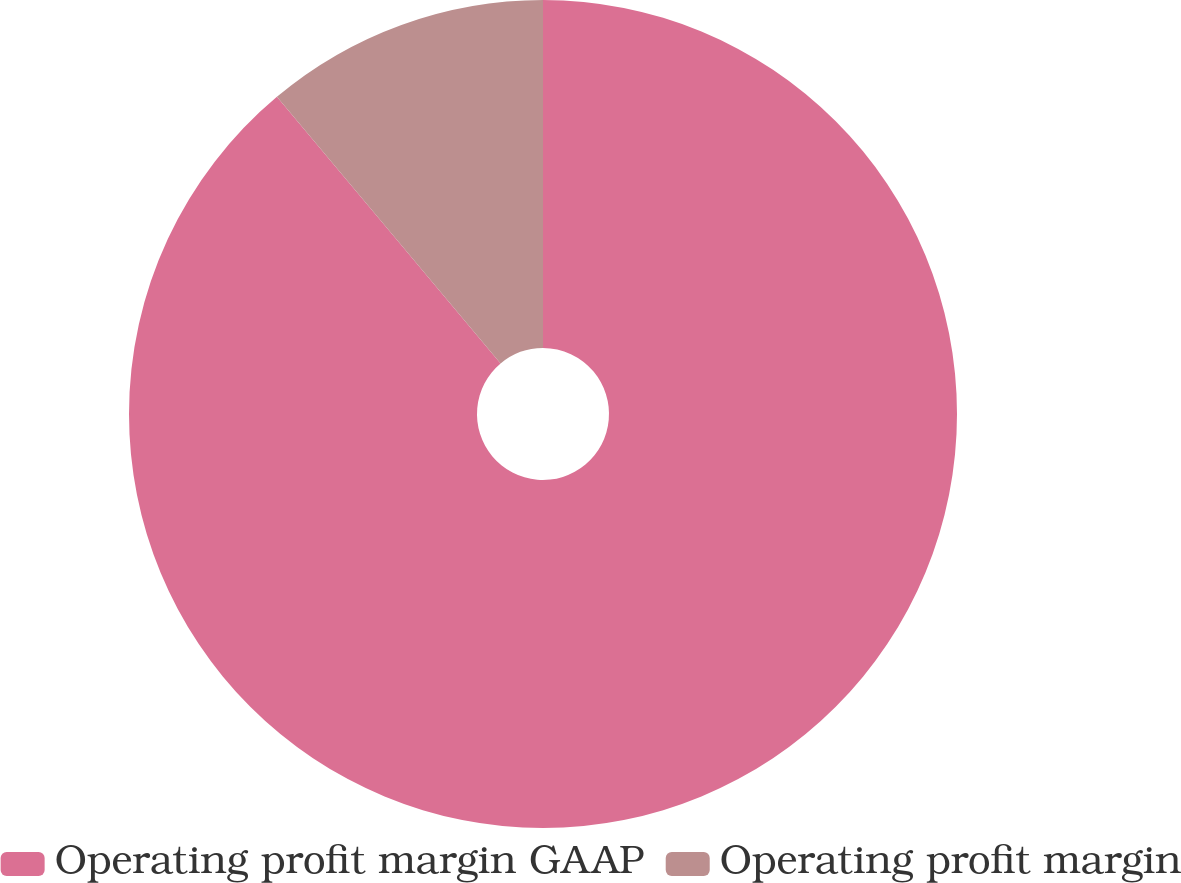<chart> <loc_0><loc_0><loc_500><loc_500><pie_chart><fcel>Operating profit margin GAAP<fcel>Operating profit margin<nl><fcel>88.89%<fcel>11.11%<nl></chart> 